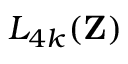Convert formula to latex. <formula><loc_0><loc_0><loc_500><loc_500>L _ { 4 k } ( Z )</formula> 